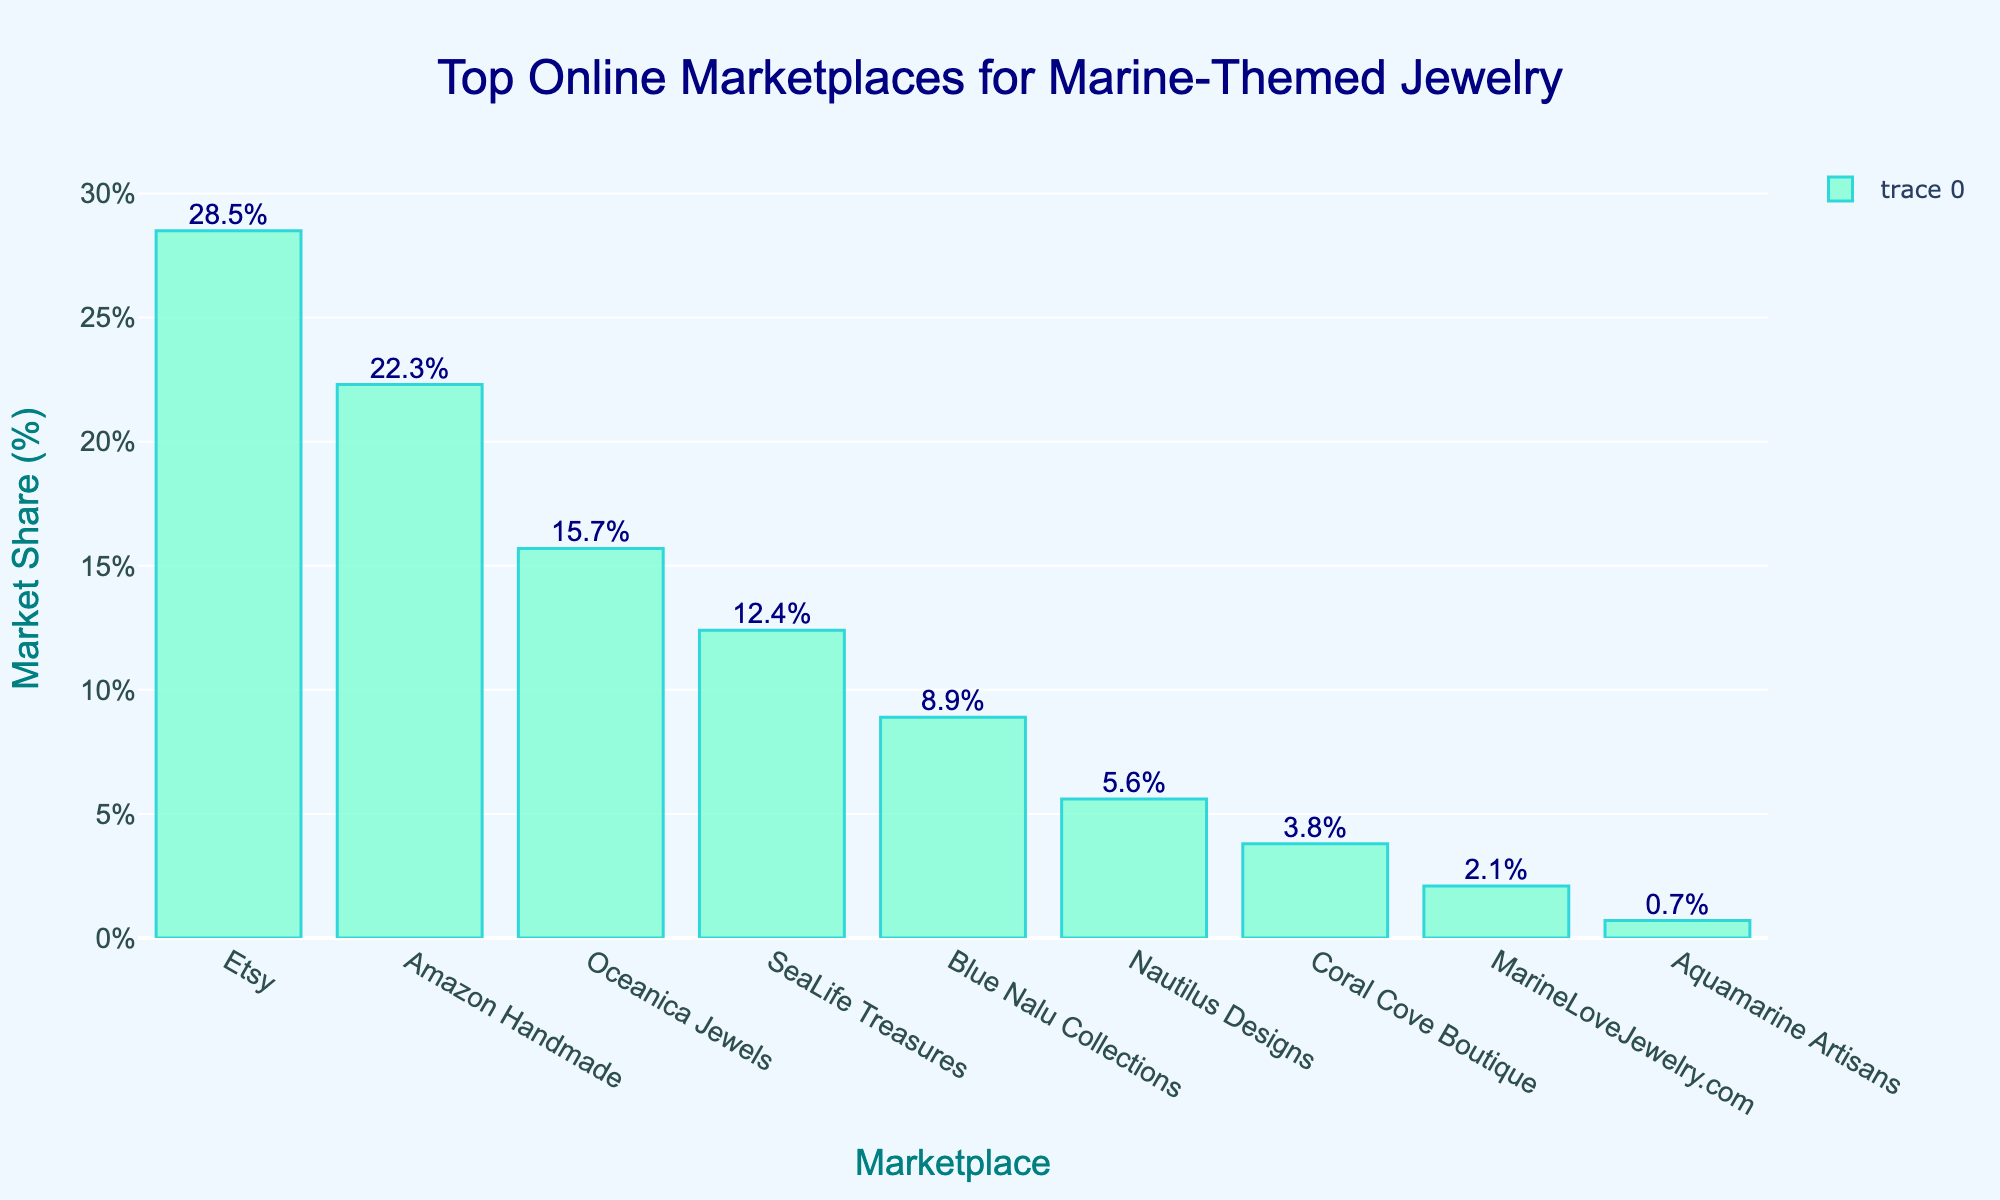what is the marketplace with the highest market share percentage The bar chart displays the market share percentages of different online marketplaces. The tallest bar represents Etsy, which has the highest market share of 28.5%.
Answer: Etsy Which marketplace has the lowest market share The bar chart’s lowest bar represents Aquamarine Artisans with a market share of 0.7%, indicating it has the smallest percentage.
Answer: Aquamarine Artisans How much more market share does Etsy have compared to Blue Nalu Collections Etsy’s market share is 28.5%, and Blue Nalu Collections is 8.9%. The difference between them is 28.5% - 8.9% = 19.6%.
Answer: 19.6% What is the combined market share of Amazon Handmade and Oceanica Jewels The market shares are 22.3% (Amazon Handmade) and 15.7% (Oceanica Jewels). Combined, this total is 22.3% + 15.7% = 38%.
Answer: 38% Which marketplace has a market share closest to 10% We look for the bar closest to 10%. SeaLife Treasures has a market share of 12.4%, which is closest to 10%.
Answer: SeaLife Treasures How many marketplaces have a market share greater than 5% The bars representing Etsy, Amazon Handmade, Oceanica Jewels, SeaLife Treasures, Blue Nalu Collections, and Nautilus Designs all exceed 5%. That’s 6 marketplaces.
Answer: 6 Which marketplace's bar is located between SeaLife Treasures and Nautilus Designs on the x-axis The marketplace between SeaLife Treasures and Nautilus Designs is Blue Nalu Collections.
Answer: Blue Nalu Collections What is the total market share of all marketplaces displayed Summing the market shares: 28.5% + 22.3% + 15.7% + 12.4% + 8.9% + 5.6% + 3.8% + 2.1% + 0.7% = 100%.
Answer: 100% Is there a noticeable difference in bar height between the top 3 marketplaces? Comparing the heights, Etsy (28.5%), Amazon Handmade (22.3%), and Oceanica Jewels (15.7%), we see significant height differences, especially between Etsy and Oceanica Jewels.
Answer: Yes 